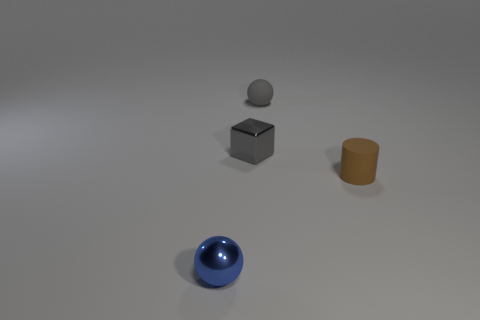What number of other things are there of the same color as the metallic block? 1 